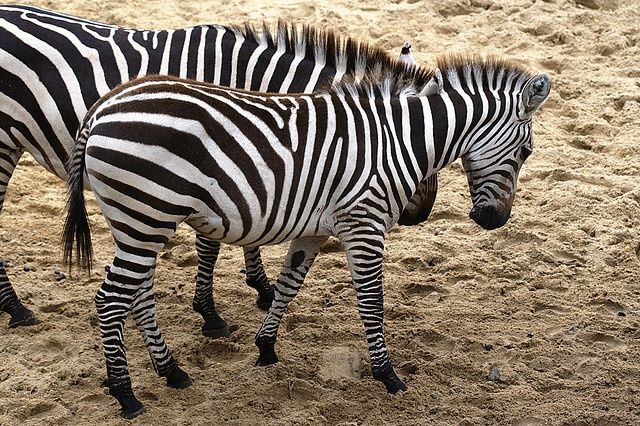Describe the objects in this image and their specific colors. I can see zebra in tan, black, lightgray, darkgray, and gray tones and zebra in tan, black, white, gray, and darkgray tones in this image. 